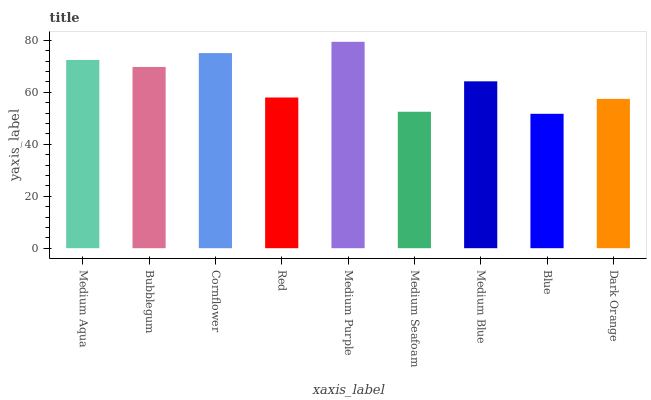Is Blue the minimum?
Answer yes or no. Yes. Is Medium Purple the maximum?
Answer yes or no. Yes. Is Bubblegum the minimum?
Answer yes or no. No. Is Bubblegum the maximum?
Answer yes or no. No. Is Medium Aqua greater than Bubblegum?
Answer yes or no. Yes. Is Bubblegum less than Medium Aqua?
Answer yes or no. Yes. Is Bubblegum greater than Medium Aqua?
Answer yes or no. No. Is Medium Aqua less than Bubblegum?
Answer yes or no. No. Is Medium Blue the high median?
Answer yes or no. Yes. Is Medium Blue the low median?
Answer yes or no. Yes. Is Cornflower the high median?
Answer yes or no. No. Is Red the low median?
Answer yes or no. No. 